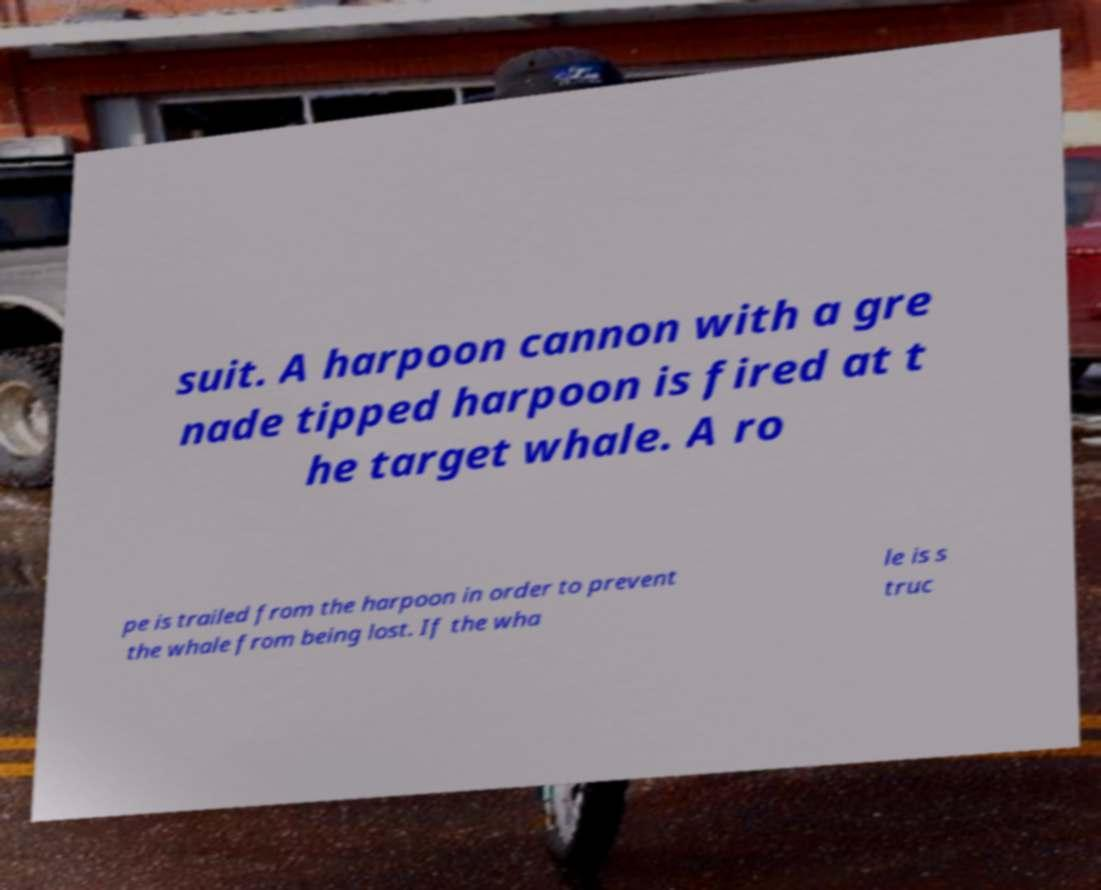Please read and relay the text visible in this image. What does it say? suit. A harpoon cannon with a gre nade tipped harpoon is fired at t he target whale. A ro pe is trailed from the harpoon in order to prevent the whale from being lost. If the wha le is s truc 